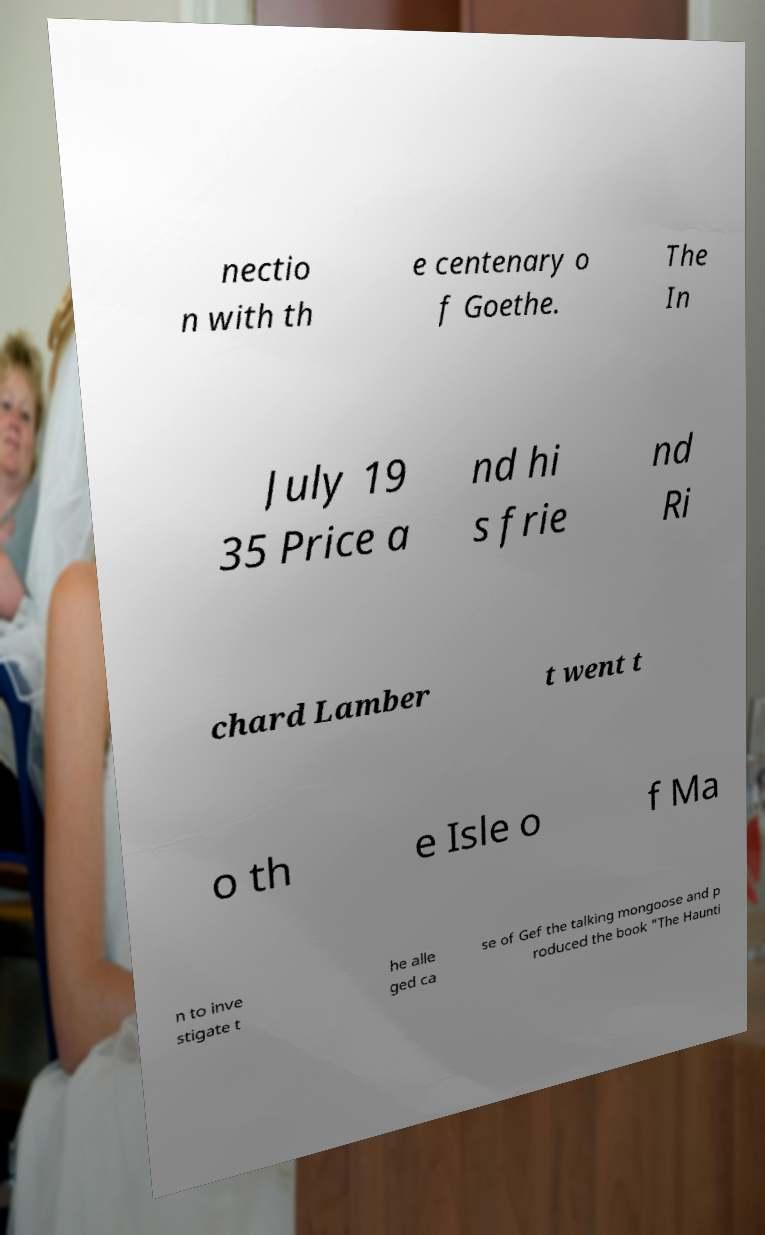Could you extract and type out the text from this image? nectio n with th e centenary o f Goethe. The In July 19 35 Price a nd hi s frie nd Ri chard Lamber t went t o th e Isle o f Ma n to inve stigate t he alle ged ca se of Gef the talking mongoose and p roduced the book "The Haunti 